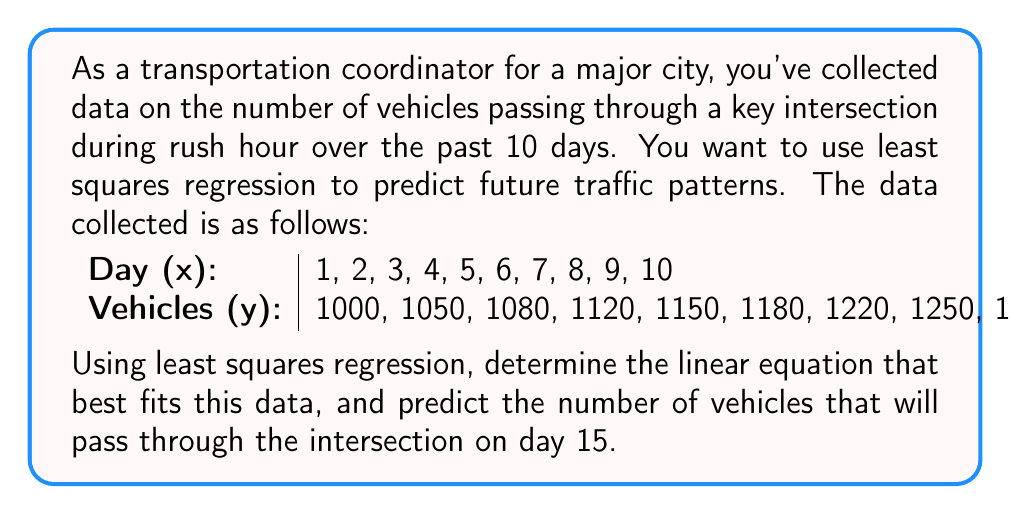Solve this math problem. To solve this problem, we'll use the least squares regression method to find the best-fit line $y = mx + b$, where $m$ is the slope and $b$ is the y-intercept.

Step 1: Calculate the necessary sums
$$\begin{align}
n &= 10 \\
\sum x &= 55 \\
\sum y &= 11660 \\
\sum xy &= 66550 \\
\sum x^2 &= 385
\end{align}$$

Step 2: Use the least squares formulas to calculate $m$ and $b$
$$m = \frac{n\sum xy - \sum x \sum y}{n\sum x^2 - (\sum x)^2}$$
$$b = \frac{\sum y - m\sum x}{n}$$

Substituting the values:
$$m = \frac{10(66550) - 55(11660)}{10(385) - 55^2} = \frac{665500 - 641300}{3850 - 3025} = \frac{24200}{825} = 29.33333$$

$$b = \frac{11660 - 29.33333(55)}{10} = \frac{11660 - 1613.33333}{10} = 1004.66667$$

Step 3: Write the equation of the best-fit line
$$y = 29.33333x + 1004.66667$$

Step 4: Predict the number of vehicles on day 15
Substitute $x = 15$ into the equation:
$$y = 29.33333(15) + 1004.66667 = 1444.66667$$

Rounding to the nearest whole number (as we can't have a fraction of a vehicle), we get 1445 vehicles.
Answer: The best-fit line equation is $y = 29.33333x + 1004.66667$, and the predicted number of vehicles passing through the intersection on day 15 is 1445. 